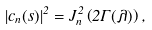<formula> <loc_0><loc_0><loc_500><loc_500>| c _ { n } ( s ) | ^ { 2 } = J _ { n } ^ { 2 } \left ( 2 \Gamma ( \lambda ) \right ) ,</formula> 